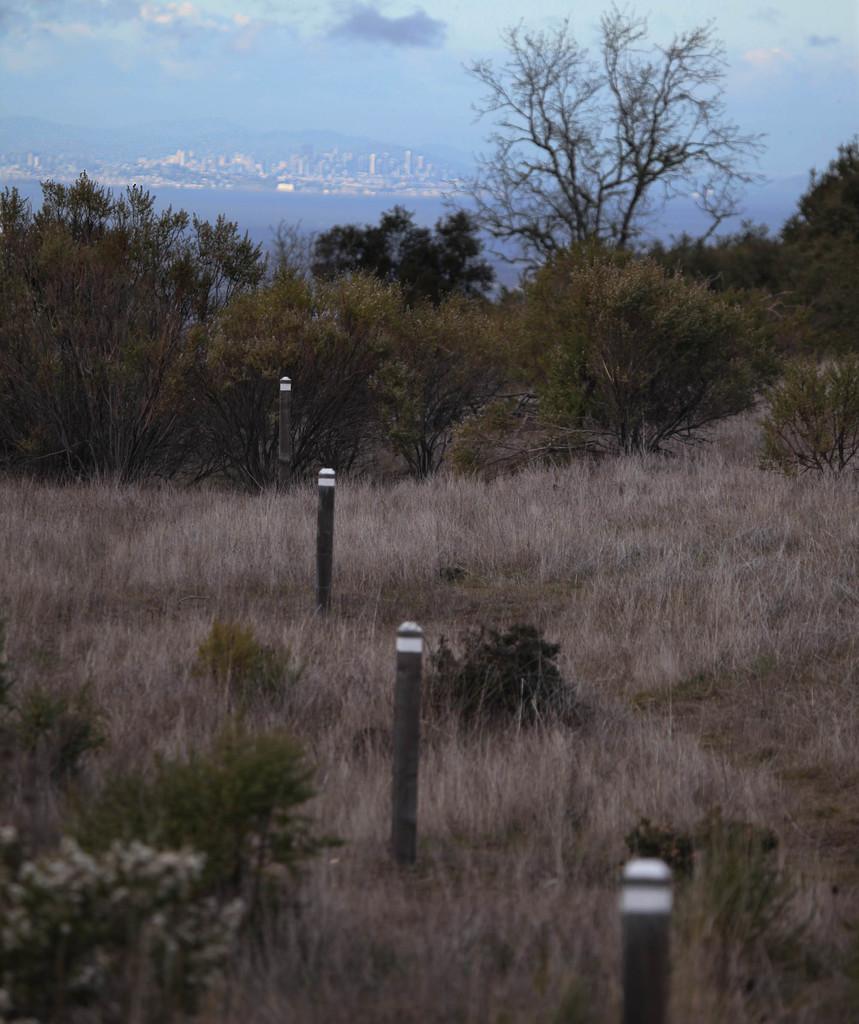Please provide a concise description of this image. In this image I can see few black and white colored poles, some grass and few trees. In the background I can see the water, few buildings and the sky. 